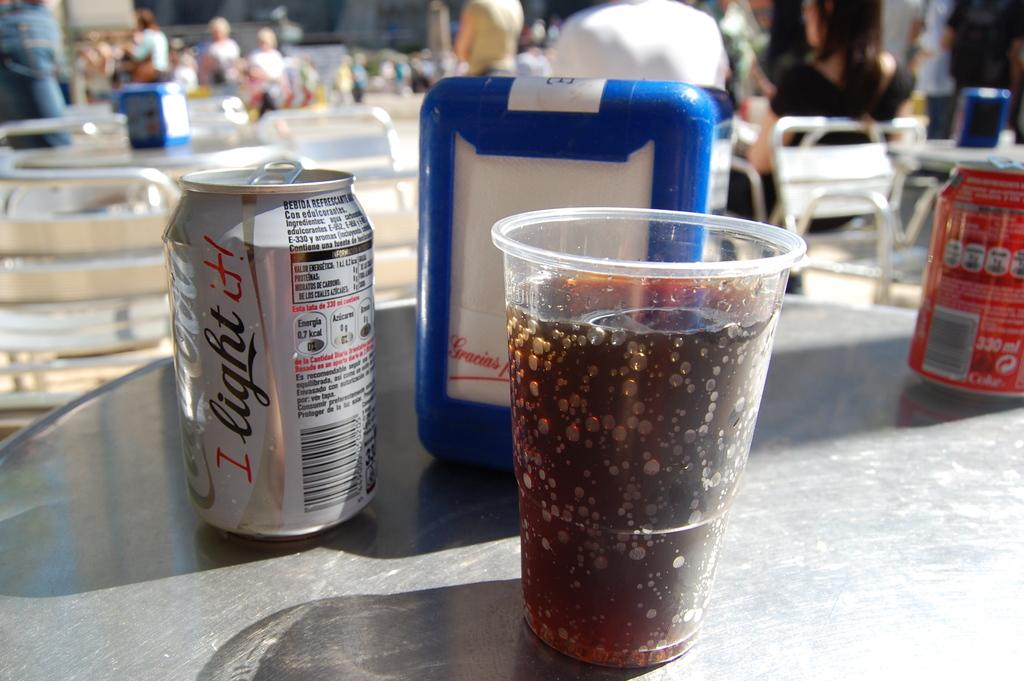<image>
Offer a succinct explanation of the picture presented. A table with a cup of soda on it and a can of diet coca cola in the background. 